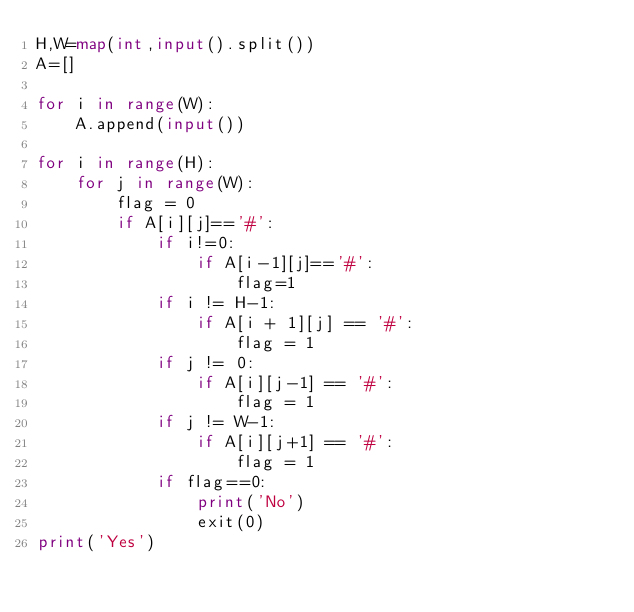<code> <loc_0><loc_0><loc_500><loc_500><_Python_>H,W=map(int,input().split())
A=[]

for i in range(W):
    A.append(input())

for i in range(H):
    for j in range(W):
        flag = 0
        if A[i][j]=='#':
            if i!=0:
                if A[i-1][j]=='#':
                    flag=1
            if i != H-1:
                if A[i + 1][j] == '#':
                    flag = 1
            if j != 0:
                if A[i][j-1] == '#':
                    flag = 1
            if j != W-1:
                if A[i][j+1] == '#':
                    flag = 1
            if flag==0:
                print('No')
                exit(0)
print('Yes')

</code> 